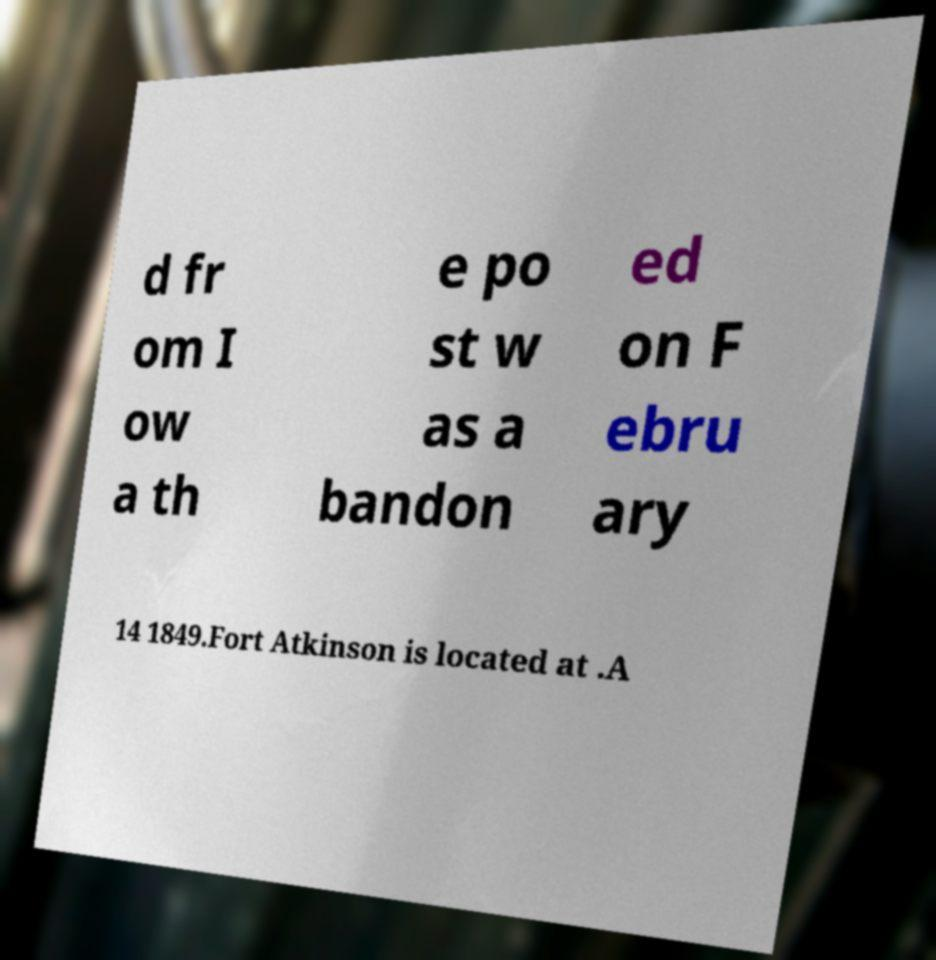Could you extract and type out the text from this image? d fr om I ow a th e po st w as a bandon ed on F ebru ary 14 1849.Fort Atkinson is located at .A 